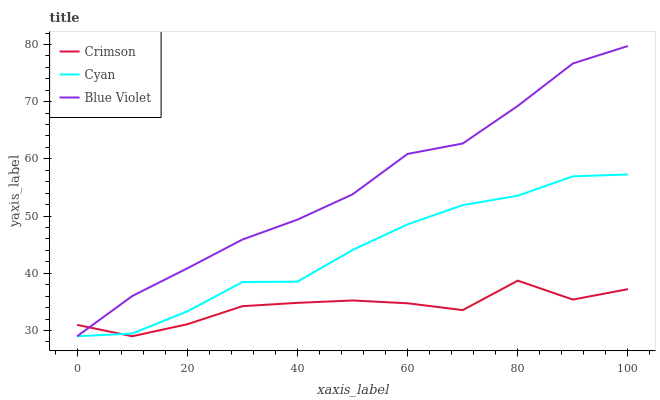Does Crimson have the minimum area under the curve?
Answer yes or no. Yes. Does Blue Violet have the maximum area under the curve?
Answer yes or no. Yes. Does Cyan have the minimum area under the curve?
Answer yes or no. No. Does Cyan have the maximum area under the curve?
Answer yes or no. No. Is Blue Violet the smoothest?
Answer yes or no. Yes. Is Crimson the roughest?
Answer yes or no. Yes. Is Cyan the smoothest?
Answer yes or no. No. Is Cyan the roughest?
Answer yes or no. No. Does Crimson have the lowest value?
Answer yes or no. Yes. Does Blue Violet have the highest value?
Answer yes or no. Yes. Does Cyan have the highest value?
Answer yes or no. No. Does Crimson intersect Cyan?
Answer yes or no. Yes. Is Crimson less than Cyan?
Answer yes or no. No. Is Crimson greater than Cyan?
Answer yes or no. No. 